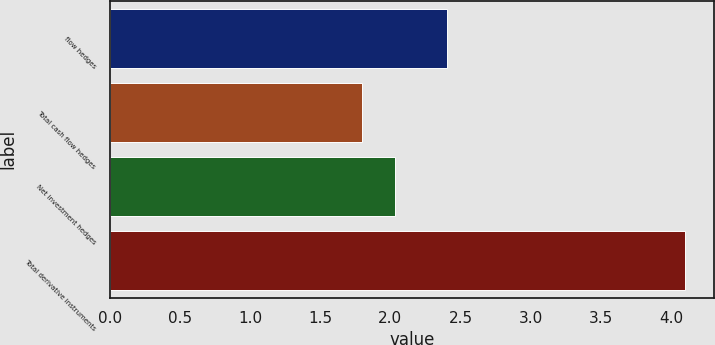Convert chart. <chart><loc_0><loc_0><loc_500><loc_500><bar_chart><fcel>flow hedges<fcel>Total cash flow hedges<fcel>Net investment hedges<fcel>Total derivative instruments<nl><fcel>2.4<fcel>1.8<fcel>2.03<fcel>4.1<nl></chart> 